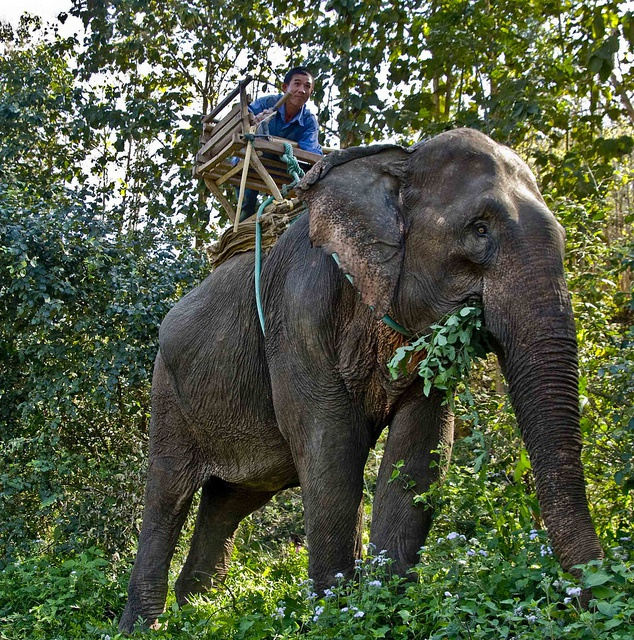Describe the objects in this image and their specific colors. I can see elephant in white, black, and gray tones, bench in white, black, gray, darkgray, and darkgreen tones, and people in white, navy, black, gray, and maroon tones in this image. 